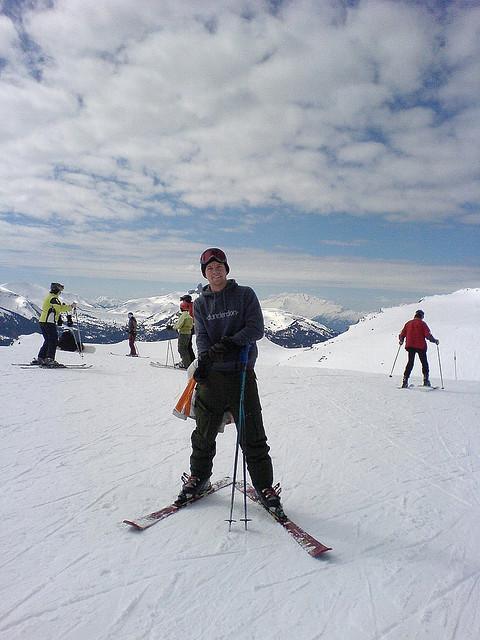How many skiers are there?
Give a very brief answer. 5. How many train tracks are shown in the photo?
Give a very brief answer. 0. 